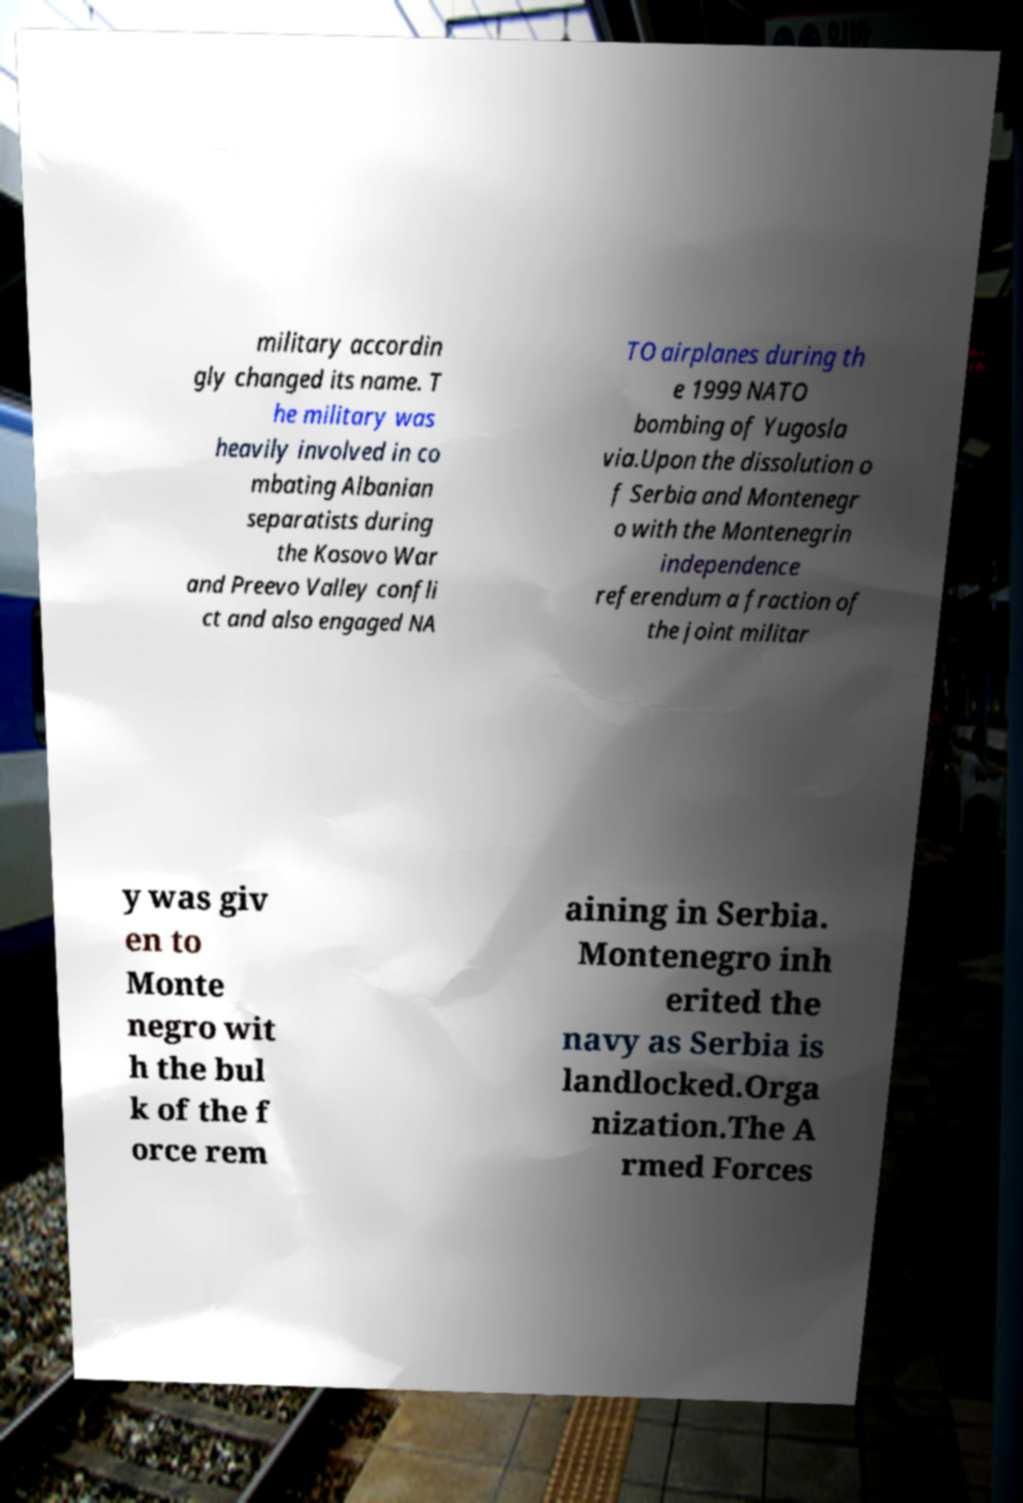Could you extract and type out the text from this image? military accordin gly changed its name. T he military was heavily involved in co mbating Albanian separatists during the Kosovo War and Preevo Valley confli ct and also engaged NA TO airplanes during th e 1999 NATO bombing of Yugosla via.Upon the dissolution o f Serbia and Montenegr o with the Montenegrin independence referendum a fraction of the joint militar y was giv en to Monte negro wit h the bul k of the f orce rem aining in Serbia. Montenegro inh erited the navy as Serbia is landlocked.Orga nization.The A rmed Forces 